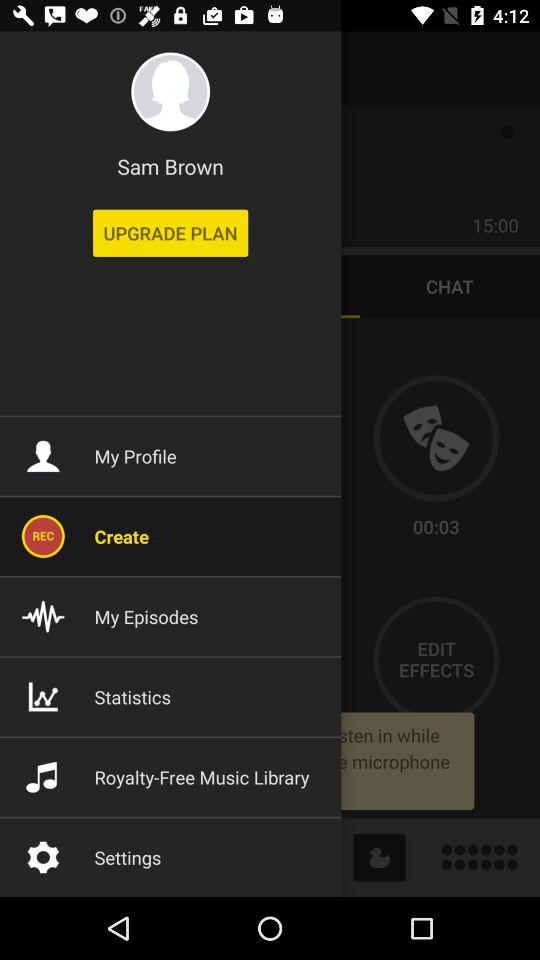What is the user name? The user name is Sam Brown. 